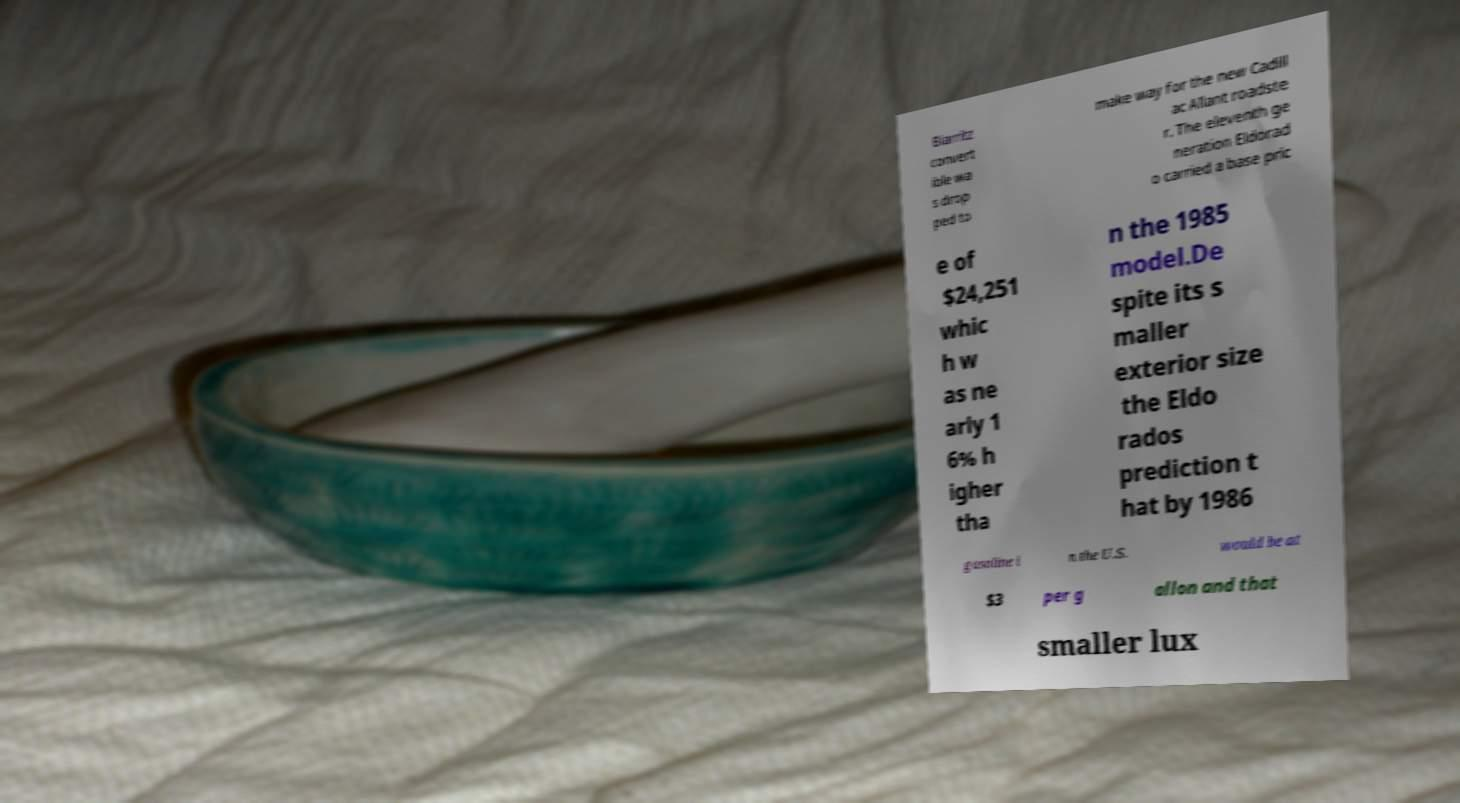Could you extract and type out the text from this image? Biarritz convert ible wa s drop ped to make way for the new Cadill ac Allant roadste r. The eleventh ge neration Eldorad o carried a base pric e of $24,251 whic h w as ne arly 1 6% h igher tha n the 1985 model.De spite its s maller exterior size the Eldo rados prediction t hat by 1986 gasoline i n the U.S. would be at $3 per g allon and that smaller lux 